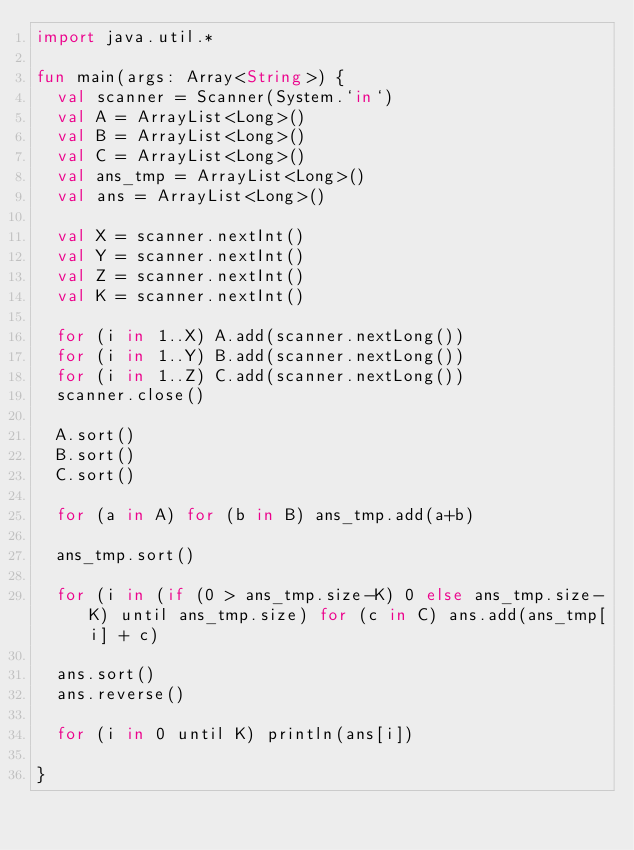Convert code to text. <code><loc_0><loc_0><loc_500><loc_500><_Kotlin_>import java.util.*

fun main(args: Array<String>) {
  val scanner = Scanner(System.`in`)
  val A = ArrayList<Long>()
  val B = ArrayList<Long>()
  val C = ArrayList<Long>()
  val ans_tmp = ArrayList<Long>()
  val ans = ArrayList<Long>()

  val X = scanner.nextInt()
  val Y = scanner.nextInt()
  val Z = scanner.nextInt()
  val K = scanner.nextInt()

  for (i in 1..X) A.add(scanner.nextLong())
  for (i in 1..Y) B.add(scanner.nextLong())
  for (i in 1..Z) C.add(scanner.nextLong())
  scanner.close()

  A.sort()
  B.sort()
  C.sort()

  for (a in A) for (b in B) ans_tmp.add(a+b)

  ans_tmp.sort()

  for (i in (if (0 > ans_tmp.size-K) 0 else ans_tmp.size-K) until ans_tmp.size) for (c in C) ans.add(ans_tmp[i] + c)

  ans.sort()
  ans.reverse()

  for (i in 0 until K) println(ans[i])

}</code> 